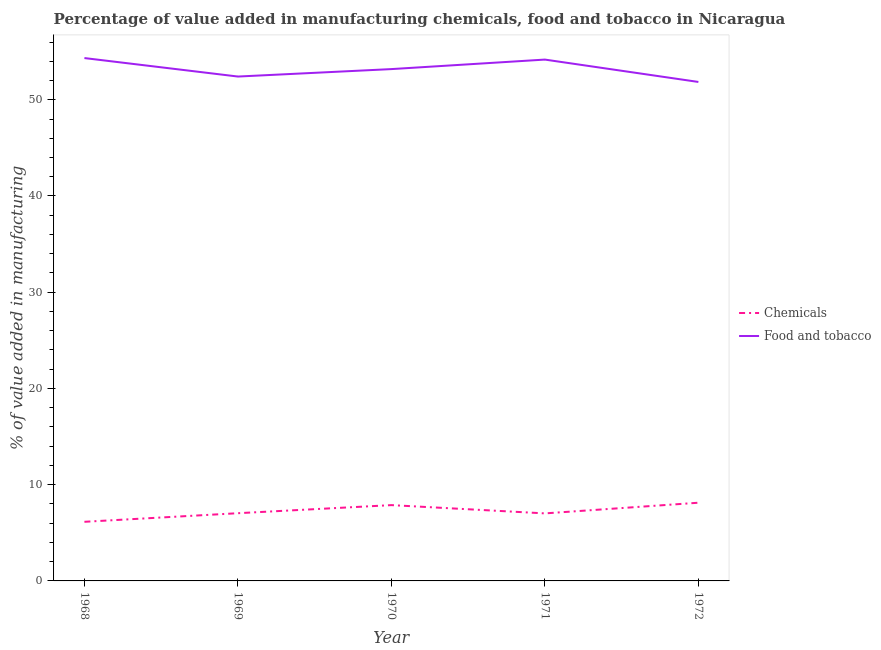How many different coloured lines are there?
Your response must be concise. 2. Is the number of lines equal to the number of legend labels?
Give a very brief answer. Yes. What is the value added by manufacturing food and tobacco in 1971?
Provide a short and direct response. 54.18. Across all years, what is the maximum value added by manufacturing food and tobacco?
Offer a terse response. 54.33. Across all years, what is the minimum value added by manufacturing food and tobacco?
Your answer should be very brief. 51.85. In which year was the value added by  manufacturing chemicals maximum?
Offer a terse response. 1972. In which year was the value added by manufacturing food and tobacco minimum?
Provide a succinct answer. 1972. What is the total value added by manufacturing food and tobacco in the graph?
Make the answer very short. 265.96. What is the difference between the value added by  manufacturing chemicals in 1968 and that in 1972?
Keep it short and to the point. -1.98. What is the difference between the value added by manufacturing food and tobacco in 1972 and the value added by  manufacturing chemicals in 1971?
Your answer should be very brief. 44.83. What is the average value added by manufacturing food and tobacco per year?
Offer a terse response. 53.19. In the year 1971, what is the difference between the value added by manufacturing food and tobacco and value added by  manufacturing chemicals?
Provide a succinct answer. 47.16. What is the ratio of the value added by manufacturing food and tobacco in 1968 to that in 1971?
Provide a succinct answer. 1. Is the value added by manufacturing food and tobacco in 1968 less than that in 1972?
Ensure brevity in your answer.  No. Is the difference between the value added by manufacturing food and tobacco in 1970 and 1971 greater than the difference between the value added by  manufacturing chemicals in 1970 and 1971?
Provide a succinct answer. No. What is the difference between the highest and the second highest value added by  manufacturing chemicals?
Ensure brevity in your answer.  0.25. What is the difference between the highest and the lowest value added by manufacturing food and tobacco?
Your answer should be very brief. 2.48. How many lines are there?
Ensure brevity in your answer.  2. How many years are there in the graph?
Ensure brevity in your answer.  5. What is the difference between two consecutive major ticks on the Y-axis?
Give a very brief answer. 10. Are the values on the major ticks of Y-axis written in scientific E-notation?
Give a very brief answer. No. Where does the legend appear in the graph?
Offer a terse response. Center right. How many legend labels are there?
Offer a terse response. 2. How are the legend labels stacked?
Offer a terse response. Vertical. What is the title of the graph?
Provide a short and direct response. Percentage of value added in manufacturing chemicals, food and tobacco in Nicaragua. What is the label or title of the X-axis?
Provide a short and direct response. Year. What is the label or title of the Y-axis?
Ensure brevity in your answer.  % of value added in manufacturing. What is the % of value added in manufacturing in Chemicals in 1968?
Provide a succinct answer. 6.14. What is the % of value added in manufacturing of Food and tobacco in 1968?
Offer a very short reply. 54.33. What is the % of value added in manufacturing of Chemicals in 1969?
Your answer should be very brief. 7.04. What is the % of value added in manufacturing of Food and tobacco in 1969?
Offer a terse response. 52.41. What is the % of value added in manufacturing in Chemicals in 1970?
Provide a short and direct response. 7.88. What is the % of value added in manufacturing of Food and tobacco in 1970?
Keep it short and to the point. 53.19. What is the % of value added in manufacturing of Chemicals in 1971?
Give a very brief answer. 7.02. What is the % of value added in manufacturing of Food and tobacco in 1971?
Your answer should be compact. 54.18. What is the % of value added in manufacturing in Chemicals in 1972?
Your response must be concise. 8.13. What is the % of value added in manufacturing in Food and tobacco in 1972?
Make the answer very short. 51.85. Across all years, what is the maximum % of value added in manufacturing in Chemicals?
Offer a terse response. 8.13. Across all years, what is the maximum % of value added in manufacturing of Food and tobacco?
Provide a succinct answer. 54.33. Across all years, what is the minimum % of value added in manufacturing in Chemicals?
Keep it short and to the point. 6.14. Across all years, what is the minimum % of value added in manufacturing in Food and tobacco?
Make the answer very short. 51.85. What is the total % of value added in manufacturing of Chemicals in the graph?
Provide a succinct answer. 36.2. What is the total % of value added in manufacturing of Food and tobacco in the graph?
Offer a terse response. 265.96. What is the difference between the % of value added in manufacturing of Chemicals in 1968 and that in 1969?
Your answer should be very brief. -0.89. What is the difference between the % of value added in manufacturing of Food and tobacco in 1968 and that in 1969?
Your answer should be very brief. 1.92. What is the difference between the % of value added in manufacturing of Chemicals in 1968 and that in 1970?
Offer a terse response. -1.73. What is the difference between the % of value added in manufacturing of Food and tobacco in 1968 and that in 1970?
Your answer should be very brief. 1.15. What is the difference between the % of value added in manufacturing of Chemicals in 1968 and that in 1971?
Provide a succinct answer. -0.87. What is the difference between the % of value added in manufacturing in Food and tobacco in 1968 and that in 1971?
Make the answer very short. 0.16. What is the difference between the % of value added in manufacturing in Chemicals in 1968 and that in 1972?
Provide a short and direct response. -1.98. What is the difference between the % of value added in manufacturing of Food and tobacco in 1968 and that in 1972?
Your answer should be very brief. 2.48. What is the difference between the % of value added in manufacturing of Chemicals in 1969 and that in 1970?
Ensure brevity in your answer.  -0.84. What is the difference between the % of value added in manufacturing in Food and tobacco in 1969 and that in 1970?
Your answer should be compact. -0.77. What is the difference between the % of value added in manufacturing in Chemicals in 1969 and that in 1971?
Your answer should be very brief. 0.02. What is the difference between the % of value added in manufacturing of Food and tobacco in 1969 and that in 1971?
Provide a succinct answer. -1.76. What is the difference between the % of value added in manufacturing in Chemicals in 1969 and that in 1972?
Provide a short and direct response. -1.09. What is the difference between the % of value added in manufacturing of Food and tobacco in 1969 and that in 1972?
Your answer should be compact. 0.56. What is the difference between the % of value added in manufacturing of Chemicals in 1970 and that in 1971?
Provide a short and direct response. 0.86. What is the difference between the % of value added in manufacturing in Food and tobacco in 1970 and that in 1971?
Your response must be concise. -0.99. What is the difference between the % of value added in manufacturing of Chemicals in 1970 and that in 1972?
Provide a short and direct response. -0.25. What is the difference between the % of value added in manufacturing of Food and tobacco in 1970 and that in 1972?
Your answer should be very brief. 1.34. What is the difference between the % of value added in manufacturing of Chemicals in 1971 and that in 1972?
Provide a short and direct response. -1.11. What is the difference between the % of value added in manufacturing in Food and tobacco in 1971 and that in 1972?
Your answer should be very brief. 2.32. What is the difference between the % of value added in manufacturing in Chemicals in 1968 and the % of value added in manufacturing in Food and tobacco in 1969?
Provide a short and direct response. -46.27. What is the difference between the % of value added in manufacturing of Chemicals in 1968 and the % of value added in manufacturing of Food and tobacco in 1970?
Give a very brief answer. -47.04. What is the difference between the % of value added in manufacturing of Chemicals in 1968 and the % of value added in manufacturing of Food and tobacco in 1971?
Provide a short and direct response. -48.03. What is the difference between the % of value added in manufacturing in Chemicals in 1968 and the % of value added in manufacturing in Food and tobacco in 1972?
Your answer should be very brief. -45.71. What is the difference between the % of value added in manufacturing in Chemicals in 1969 and the % of value added in manufacturing in Food and tobacco in 1970?
Offer a terse response. -46.15. What is the difference between the % of value added in manufacturing of Chemicals in 1969 and the % of value added in manufacturing of Food and tobacco in 1971?
Make the answer very short. -47.14. What is the difference between the % of value added in manufacturing of Chemicals in 1969 and the % of value added in manufacturing of Food and tobacco in 1972?
Give a very brief answer. -44.81. What is the difference between the % of value added in manufacturing in Chemicals in 1970 and the % of value added in manufacturing in Food and tobacco in 1971?
Keep it short and to the point. -46.3. What is the difference between the % of value added in manufacturing of Chemicals in 1970 and the % of value added in manufacturing of Food and tobacco in 1972?
Your response must be concise. -43.97. What is the difference between the % of value added in manufacturing in Chemicals in 1971 and the % of value added in manufacturing in Food and tobacco in 1972?
Offer a very short reply. -44.83. What is the average % of value added in manufacturing of Chemicals per year?
Ensure brevity in your answer.  7.24. What is the average % of value added in manufacturing of Food and tobacco per year?
Your response must be concise. 53.19. In the year 1968, what is the difference between the % of value added in manufacturing in Chemicals and % of value added in manufacturing in Food and tobacco?
Make the answer very short. -48.19. In the year 1969, what is the difference between the % of value added in manufacturing of Chemicals and % of value added in manufacturing of Food and tobacco?
Provide a succinct answer. -45.38. In the year 1970, what is the difference between the % of value added in manufacturing in Chemicals and % of value added in manufacturing in Food and tobacco?
Make the answer very short. -45.31. In the year 1971, what is the difference between the % of value added in manufacturing of Chemicals and % of value added in manufacturing of Food and tobacco?
Ensure brevity in your answer.  -47.16. In the year 1972, what is the difference between the % of value added in manufacturing in Chemicals and % of value added in manufacturing in Food and tobacco?
Keep it short and to the point. -43.73. What is the ratio of the % of value added in manufacturing in Chemicals in 1968 to that in 1969?
Ensure brevity in your answer.  0.87. What is the ratio of the % of value added in manufacturing in Food and tobacco in 1968 to that in 1969?
Keep it short and to the point. 1.04. What is the ratio of the % of value added in manufacturing of Chemicals in 1968 to that in 1970?
Provide a succinct answer. 0.78. What is the ratio of the % of value added in manufacturing in Food and tobacco in 1968 to that in 1970?
Offer a very short reply. 1.02. What is the ratio of the % of value added in manufacturing in Chemicals in 1968 to that in 1971?
Your answer should be very brief. 0.88. What is the ratio of the % of value added in manufacturing of Food and tobacco in 1968 to that in 1971?
Your answer should be very brief. 1. What is the ratio of the % of value added in manufacturing of Chemicals in 1968 to that in 1972?
Ensure brevity in your answer.  0.76. What is the ratio of the % of value added in manufacturing of Food and tobacco in 1968 to that in 1972?
Ensure brevity in your answer.  1.05. What is the ratio of the % of value added in manufacturing in Chemicals in 1969 to that in 1970?
Your answer should be compact. 0.89. What is the ratio of the % of value added in manufacturing of Food and tobacco in 1969 to that in 1970?
Your answer should be very brief. 0.99. What is the ratio of the % of value added in manufacturing in Chemicals in 1969 to that in 1971?
Give a very brief answer. 1. What is the ratio of the % of value added in manufacturing in Food and tobacco in 1969 to that in 1971?
Provide a succinct answer. 0.97. What is the ratio of the % of value added in manufacturing of Chemicals in 1969 to that in 1972?
Ensure brevity in your answer.  0.87. What is the ratio of the % of value added in manufacturing of Food and tobacco in 1969 to that in 1972?
Keep it short and to the point. 1.01. What is the ratio of the % of value added in manufacturing of Chemicals in 1970 to that in 1971?
Your response must be concise. 1.12. What is the ratio of the % of value added in manufacturing in Food and tobacco in 1970 to that in 1971?
Offer a very short reply. 0.98. What is the ratio of the % of value added in manufacturing in Chemicals in 1970 to that in 1972?
Your answer should be compact. 0.97. What is the ratio of the % of value added in manufacturing of Food and tobacco in 1970 to that in 1972?
Give a very brief answer. 1.03. What is the ratio of the % of value added in manufacturing of Chemicals in 1971 to that in 1972?
Your answer should be compact. 0.86. What is the ratio of the % of value added in manufacturing of Food and tobacco in 1971 to that in 1972?
Your answer should be very brief. 1.04. What is the difference between the highest and the second highest % of value added in manufacturing in Chemicals?
Give a very brief answer. 0.25. What is the difference between the highest and the second highest % of value added in manufacturing of Food and tobacco?
Provide a short and direct response. 0.16. What is the difference between the highest and the lowest % of value added in manufacturing in Chemicals?
Your response must be concise. 1.98. What is the difference between the highest and the lowest % of value added in manufacturing in Food and tobacco?
Provide a short and direct response. 2.48. 